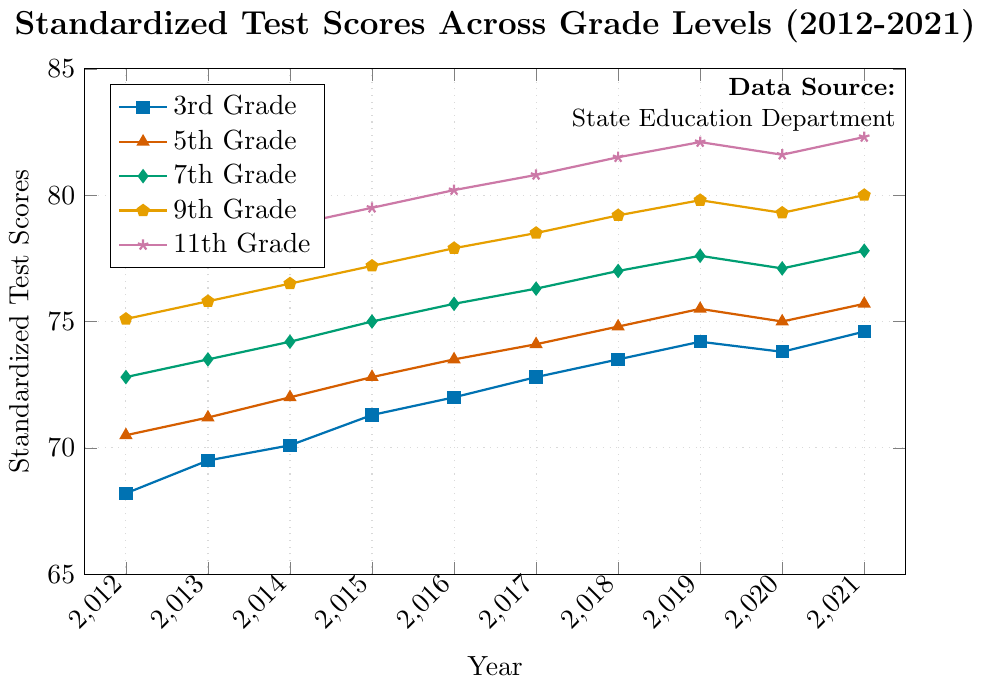How have 3rd-grade test scores changed from 2012 to 2021? Look at the data points for 3rd grade test scores in 2012 (68.2) and 2021 (74.6). The difference is 74.6 - 68.2.
Answer: 6.4 Which grade level showed the highest score in 2021? Examine the data points for all grade levels in 2021. The scores are 3rd (74.6), 5th (75.7), 7th (77.8), 9th (80.0), and 11th (82.3). 11th grade has the highest score.
Answer: 11th grade What is the average test score for 9th grade from 2012 to 2021? Add the scores for 9th grade from 2012 to 2021 and divide by the number of years: (75.1 + 75.8 + 76.5 + 77.2 + 77.9 + 78.5 + 79.2 + 79.8 + 79.3 + 80.0) / 10.  The sum is 779.3 and the average is 779.3 / 10 = 77.93.
Answer: 77.93 Between which years did the 7th grade scores show the highest increase? Calculate the yearly differences for 7th grade: 2012-2013 (0.7), 2013-2014 (0.7), 2014-2015 (0.8), 2015-2016 (0.7), 2016-2017 (0.6), 2017-2018 (0.7), 2018-2019 (0.6), 2019-2020 (-0.5), 2020-2021 (0.7). The highest increase is 0.8, between 2014 and 2015.
Answer: 2014 to 2015 What is the trend of 11th grade scores from 2012 to 2021? Observe the 11th-grade scores over the years: 77.4, 78.1, 78.8, 79.5, 80.2, 80.8, 81.5, 82.1, 81.6, 82.3. The trend is a consistent increase, with a slight drop in 2020, but overall rising.
Answer: Increasing How do the test scores of 3rd grade in 2020 compare to 2019? Compare the 3rd-grade scores in 2020 (73.8) and 2019 (74.2). The score in 2020 is lower by 0.4.
Answer: Lower Which grade level had the smallest improvement from 2012 to 2021? Calculate the difference from 2012 to 2021 for each grade: 3rd (74.6-68.2=6.4), 5th (75.7-70.5=5.2), 7th (77.8-72.8=5.0), 9th (80.0-75.1=4.9), 11th (82.3-77.4=4.9). Both 9th and 11th grades have the smallest improvements (4.9).
Answer: 9th and 11th What is the difference between the test scores of 7th grade and 5th grade in 2021? Subtract the 5th grade score in 2021 (75.7) from the 7th grade score in 2021 (77.8): 77.8 - 75.7.
Answer: 2.1 Explain the performance trend for 5th grade from 2016 to 2021. Look at the 5th grade scores: 2016 (73.5), 2017 (74.1), 2018 (74.8), 2019 (75.5), 2020 (75.0), 2021 (75.7). The scores trend upward, with a slight dip in 2020, but then continuing to increase in 2021.
Answer: Mostly increasing, with a slight dip in 2020 What is the average annual improvement in scores for 3rd grade from 2012 to 2019? Calculate the annual differences from 2012 to 2019: (69.5-68.2), (70.1-69.5), (71.3-70.1), (72.0-71.3), (72.8-72.0), (73.5-72.8), (74.2-73.5). Sum the differences and divide by the number of years. The sum is 6.0 and there are 7 years: 6.0 / 7 = 0.86.
Answer: 0.86 